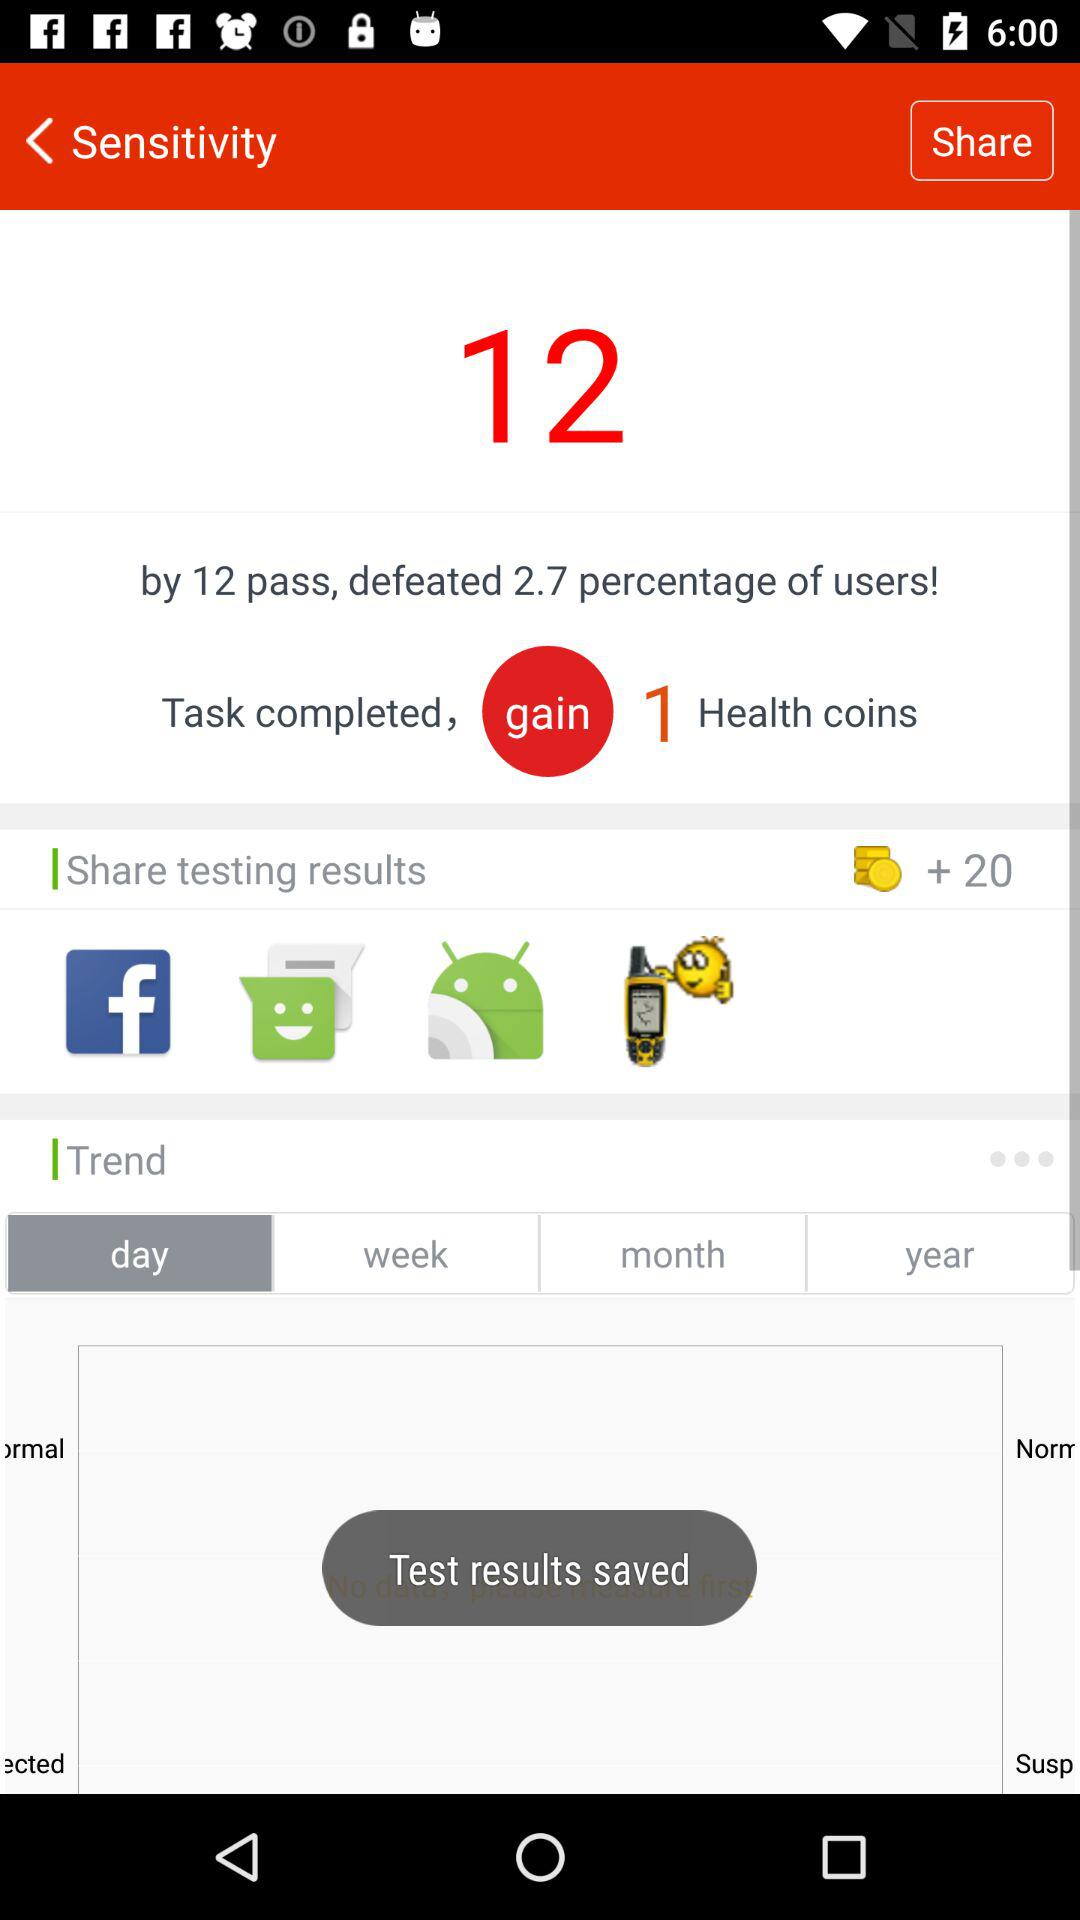What is the significance of 'Health coins' mentioned in the image? 'Health coins' likely represent a form of in-app currency or reward points that you earn for completing tasks which may be used to obtain benefits or perks within the app ecosystem. 